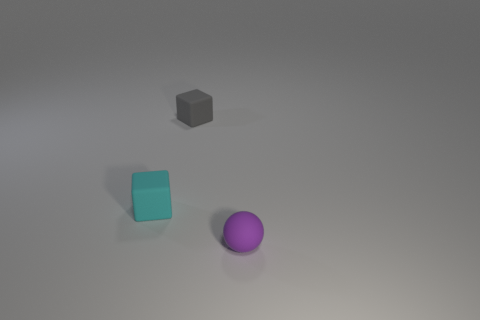Are there more tiny cubes behind the cyan cube than tiny purple matte spheres to the left of the purple rubber thing?
Make the answer very short. Yes. Is the size of the purple ball the same as the rubber block left of the gray matte thing?
Your answer should be very brief. Yes. What number of spheres are either cyan matte things or rubber objects?
Offer a very short reply. 1. Does the block that is on the right side of the small cyan rubber block have the same size as the block on the left side of the tiny gray matte object?
Your answer should be compact. Yes. What number of objects are purple objects or matte objects?
Offer a very short reply. 3. What is the shape of the tiny purple rubber thing?
Offer a very short reply. Sphere. What is the size of the cyan rubber object that is the same shape as the tiny gray rubber object?
Ensure brevity in your answer.  Small. Are there the same number of cubes on the left side of the gray rubber cube and small cyan rubber cubes?
Keep it short and to the point. Yes. Are there fewer cyan cubes that are behind the gray block than matte spheres?
Provide a short and direct response. Yes. Is there a rubber object that has the same size as the gray matte cube?
Provide a short and direct response. Yes. 